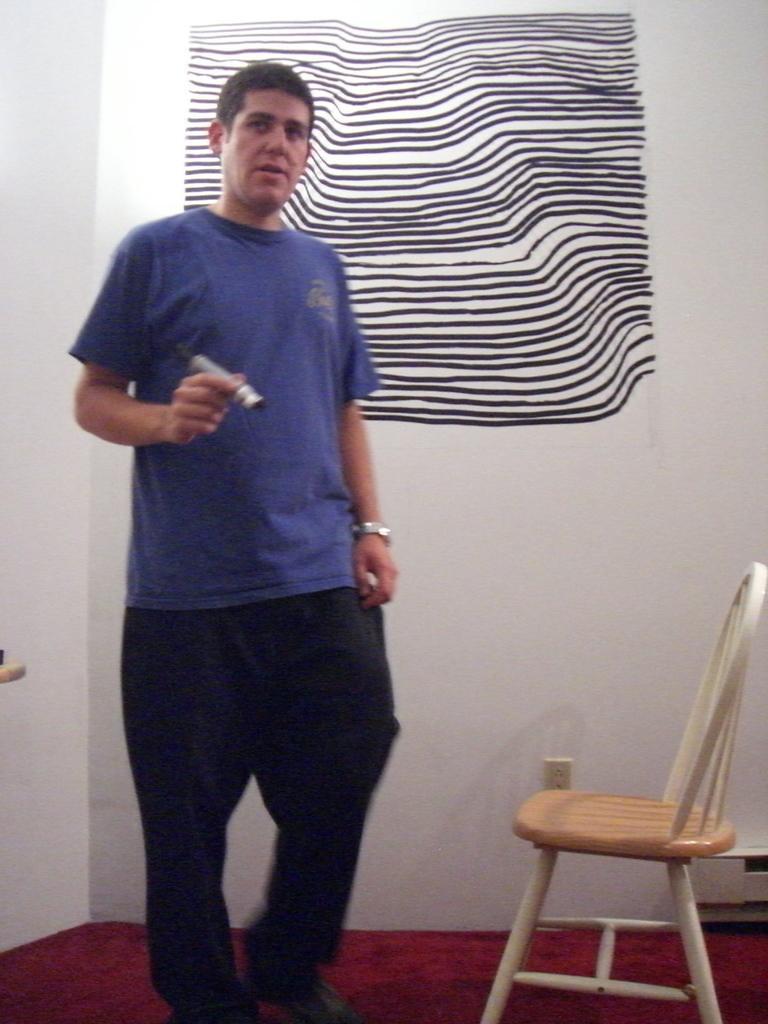Describe this image in one or two sentences. This picture is clicked inside the room. The man in blue T-shirt and black pant is holding a marker in his hand. In the right bottom of the picture, we see a chair and a red carpet. Behind him, we see a white wall and I think he is painting on the wall. 